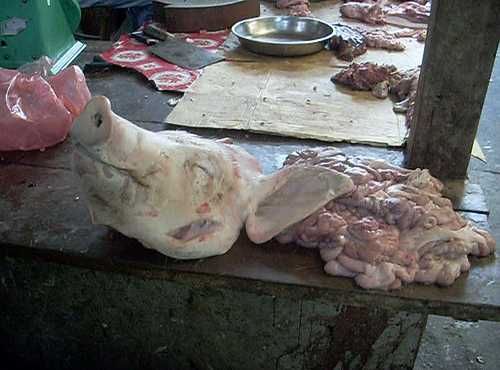<image>
Is there a pig head next to the bowl? No. The pig head is not positioned next to the bowl. They are located in different areas of the scene. Is there a pig nose in front of the bowl? Yes. The pig nose is positioned in front of the bowl, appearing closer to the camera viewpoint. 